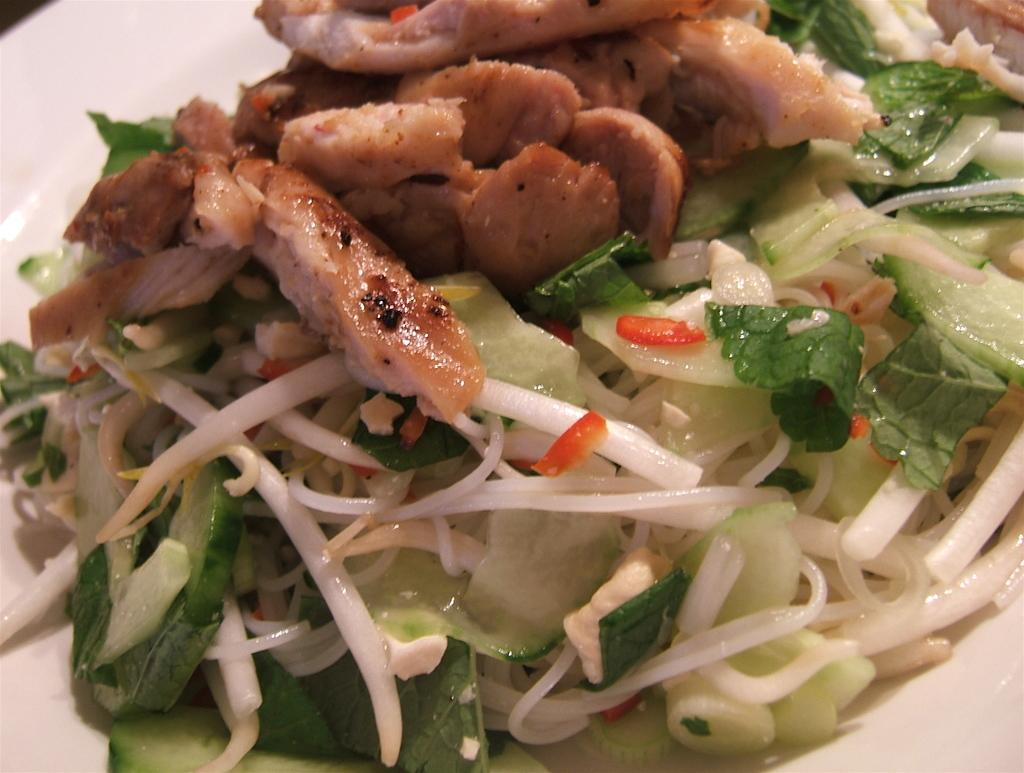What is present on the plate in the image? There is food on the plate in the image. What color is the plate? The plate is white in color. What type of thunder can be heard in the image? There is no thunder present in the image, as it is a still image and not an audio recording. 